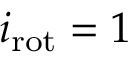Convert formula to latex. <formula><loc_0><loc_0><loc_500><loc_500>{ i _ { r o t } } = 1</formula> 